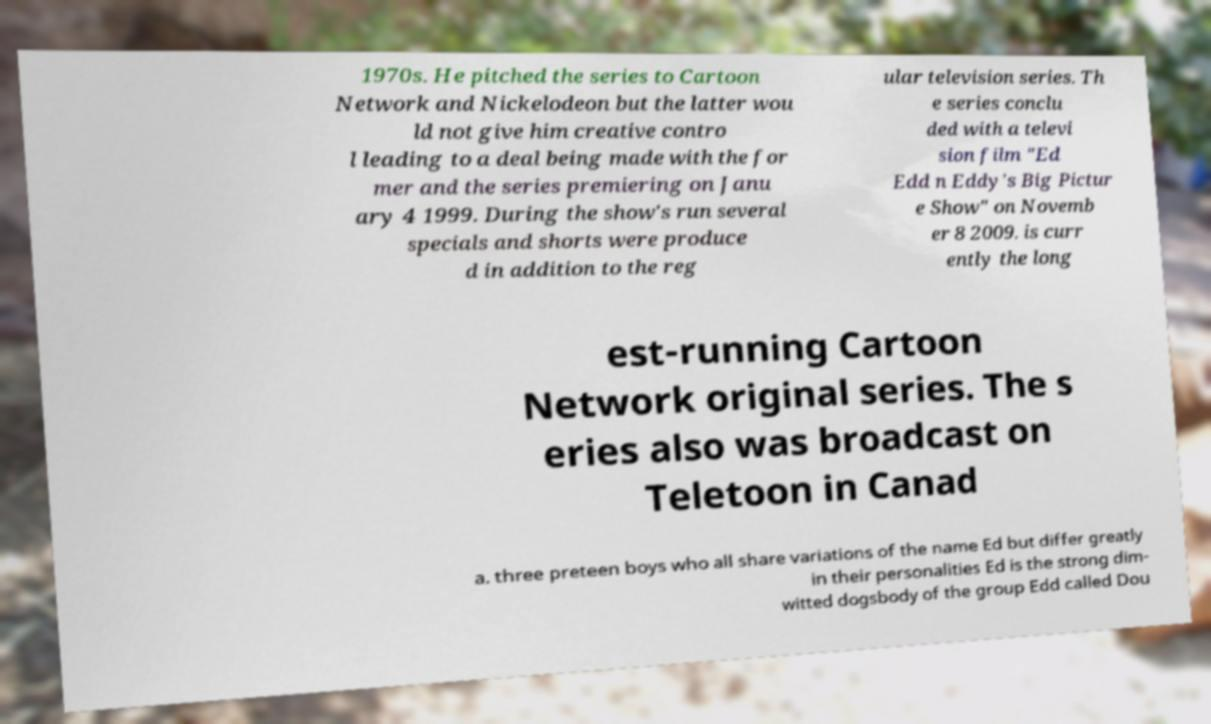Can you read and provide the text displayed in the image?This photo seems to have some interesting text. Can you extract and type it out for me? 1970s. He pitched the series to Cartoon Network and Nickelodeon but the latter wou ld not give him creative contro l leading to a deal being made with the for mer and the series premiering on Janu ary 4 1999. During the show's run several specials and shorts were produce d in addition to the reg ular television series. Th e series conclu ded with a televi sion film "Ed Edd n Eddy's Big Pictur e Show" on Novemb er 8 2009. is curr ently the long est-running Cartoon Network original series. The s eries also was broadcast on Teletoon in Canad a. three preteen boys who all share variations of the name Ed but differ greatly in their personalities Ed is the strong dim- witted dogsbody of the group Edd called Dou 